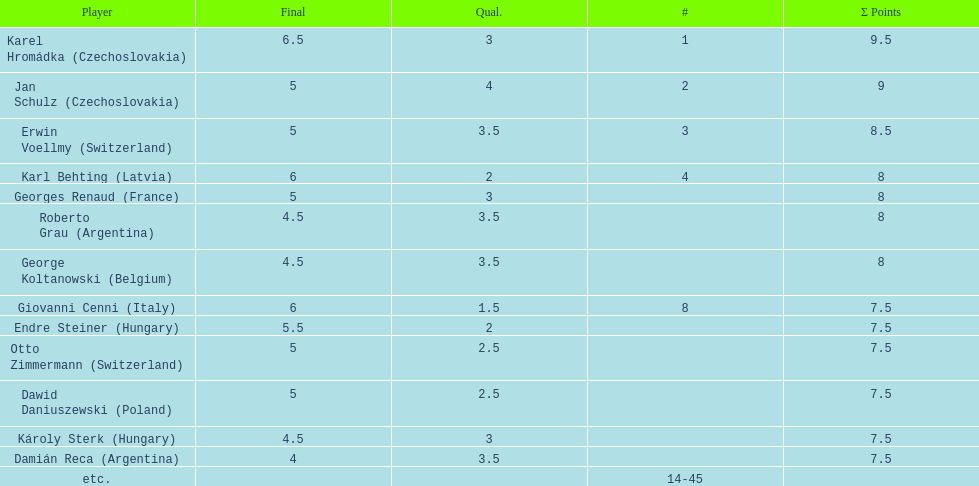Did the two competitors from hungary get more or less combined points than the two competitors from argentina? Less. 